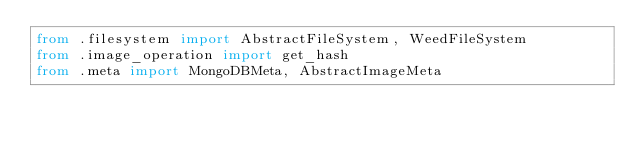<code> <loc_0><loc_0><loc_500><loc_500><_Python_>from .filesystem import AbstractFileSystem, WeedFileSystem
from .image_operation import get_hash
from .meta import MongoDBMeta, AbstractImageMeta
</code> 